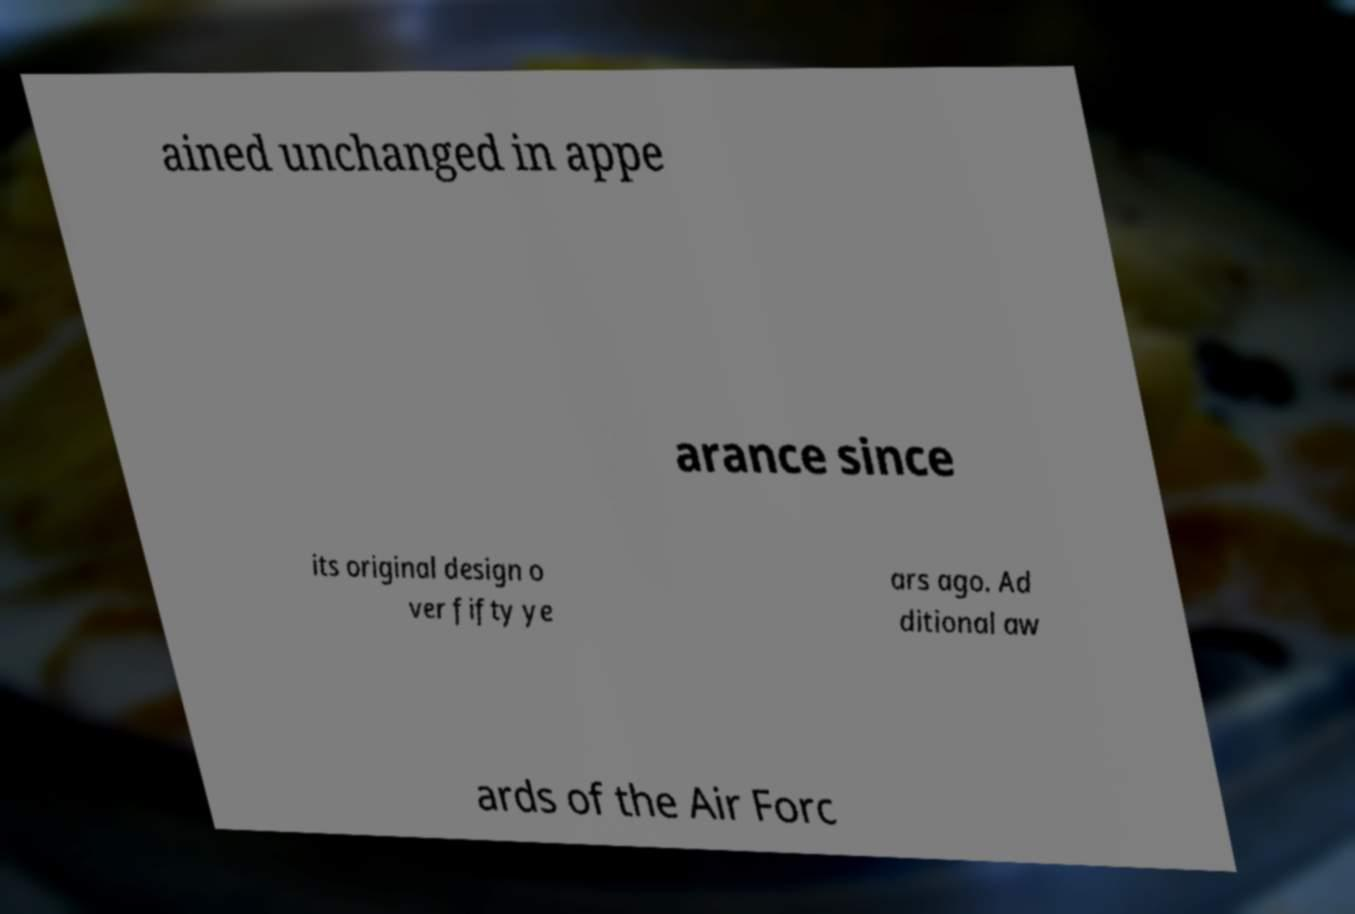I need the written content from this picture converted into text. Can you do that? ained unchanged in appe arance since its original design o ver fifty ye ars ago. Ad ditional aw ards of the Air Forc 